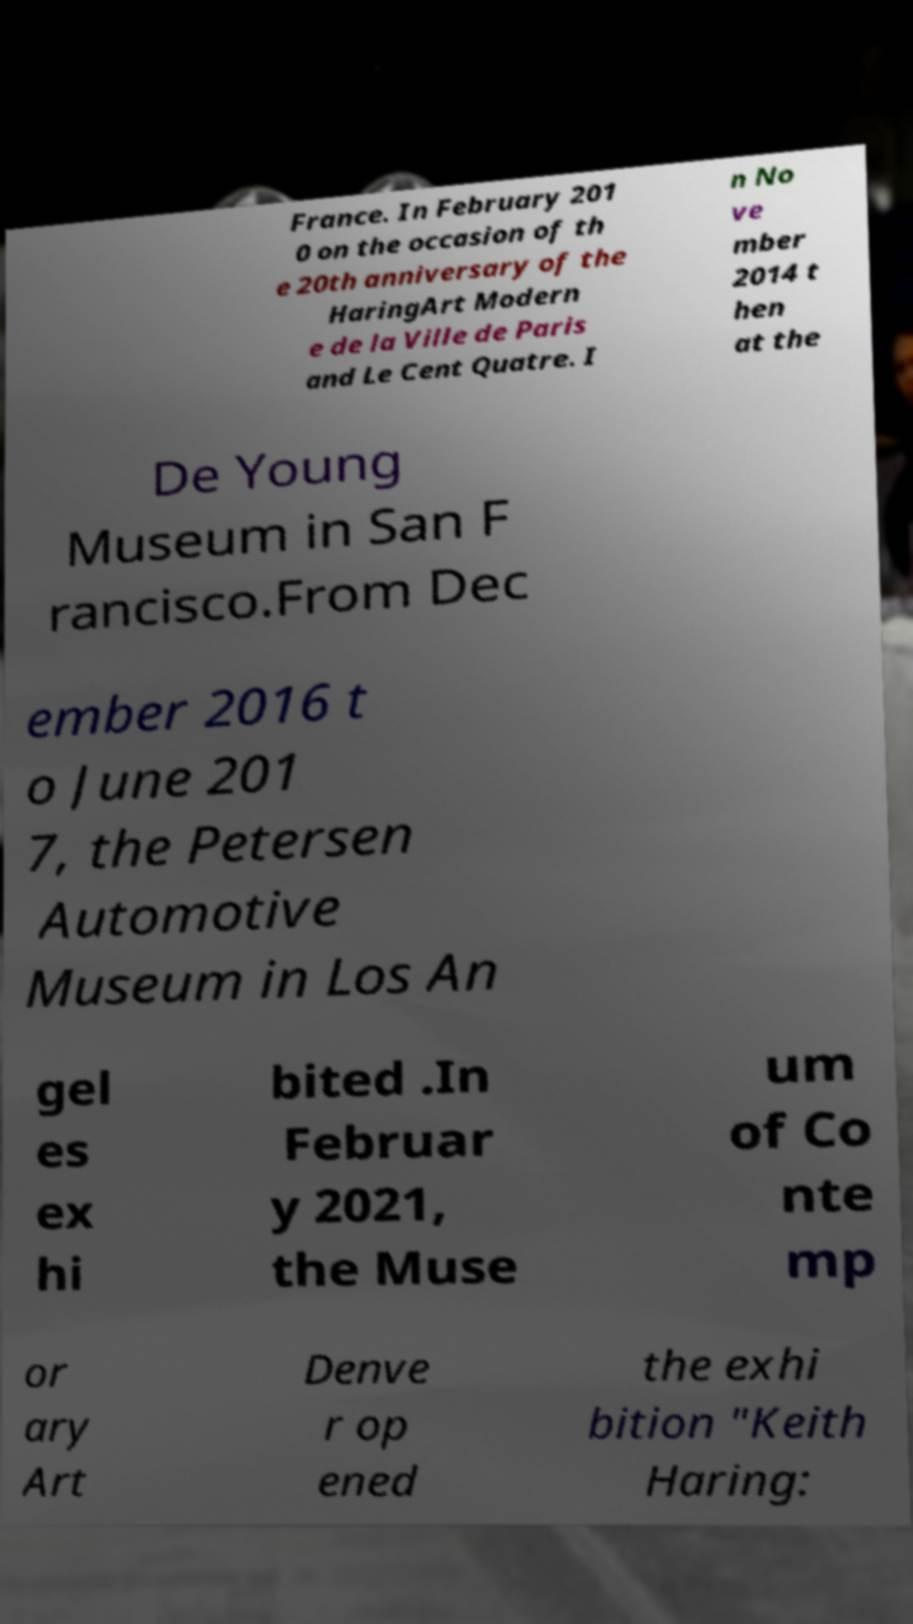Can you accurately transcribe the text from the provided image for me? France. In February 201 0 on the occasion of th e 20th anniversary of the HaringArt Modern e de la Ville de Paris and Le Cent Quatre. I n No ve mber 2014 t hen at the De Young Museum in San F rancisco.From Dec ember 2016 t o June 201 7, the Petersen Automotive Museum in Los An gel es ex hi bited .In Februar y 2021, the Muse um of Co nte mp or ary Art Denve r op ened the exhi bition "Keith Haring: 